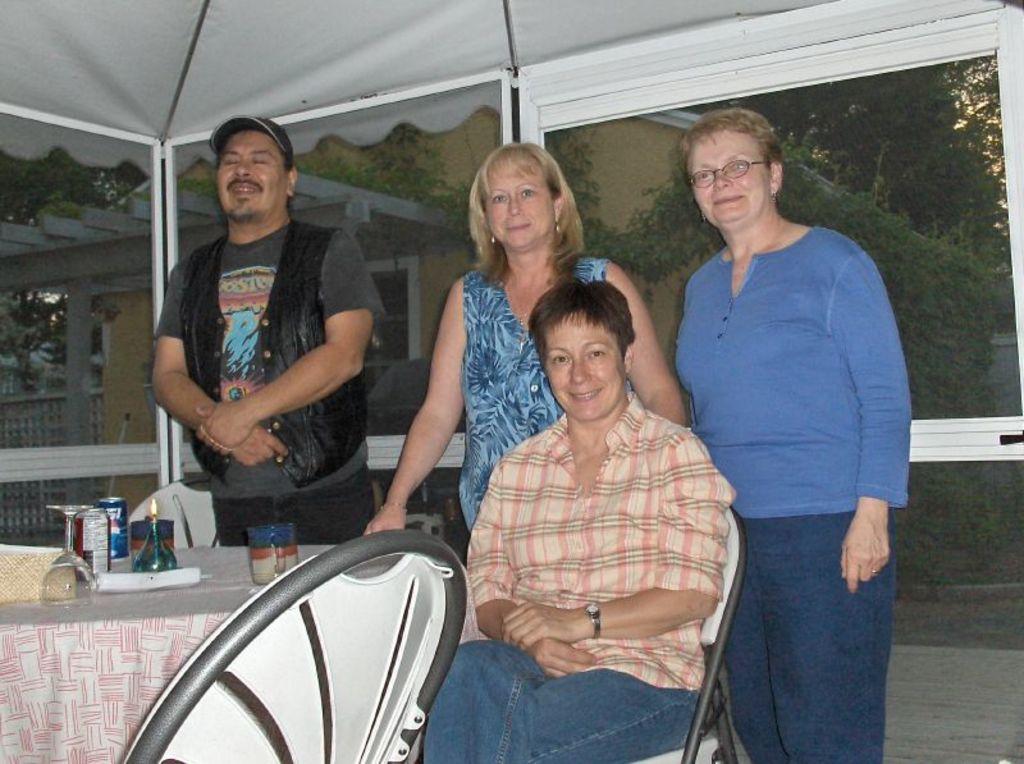How would you summarize this image in a sentence or two? In this image we can see some persons. One lady is sitting on the chair, one person is standing and closing is eyes. On the bottom left corner we can see the table and some objects on the table. 